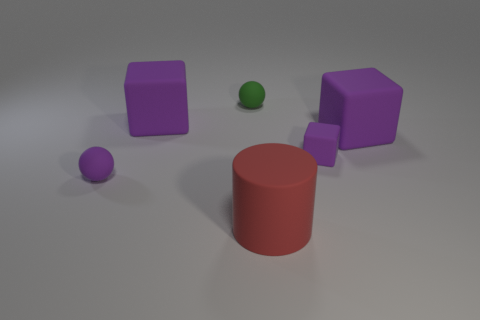Subtract all purple cubes. How many were subtracted if there are2purple cubes left? 1 Add 2 big red rubber cylinders. How many objects exist? 8 Subtract all cylinders. How many objects are left? 5 Add 6 green spheres. How many green spheres are left? 7 Add 1 tiny matte objects. How many tiny matte objects exist? 4 Subtract 0 brown spheres. How many objects are left? 6 Subtract all cyan metallic spheres. Subtract all large rubber things. How many objects are left? 3 